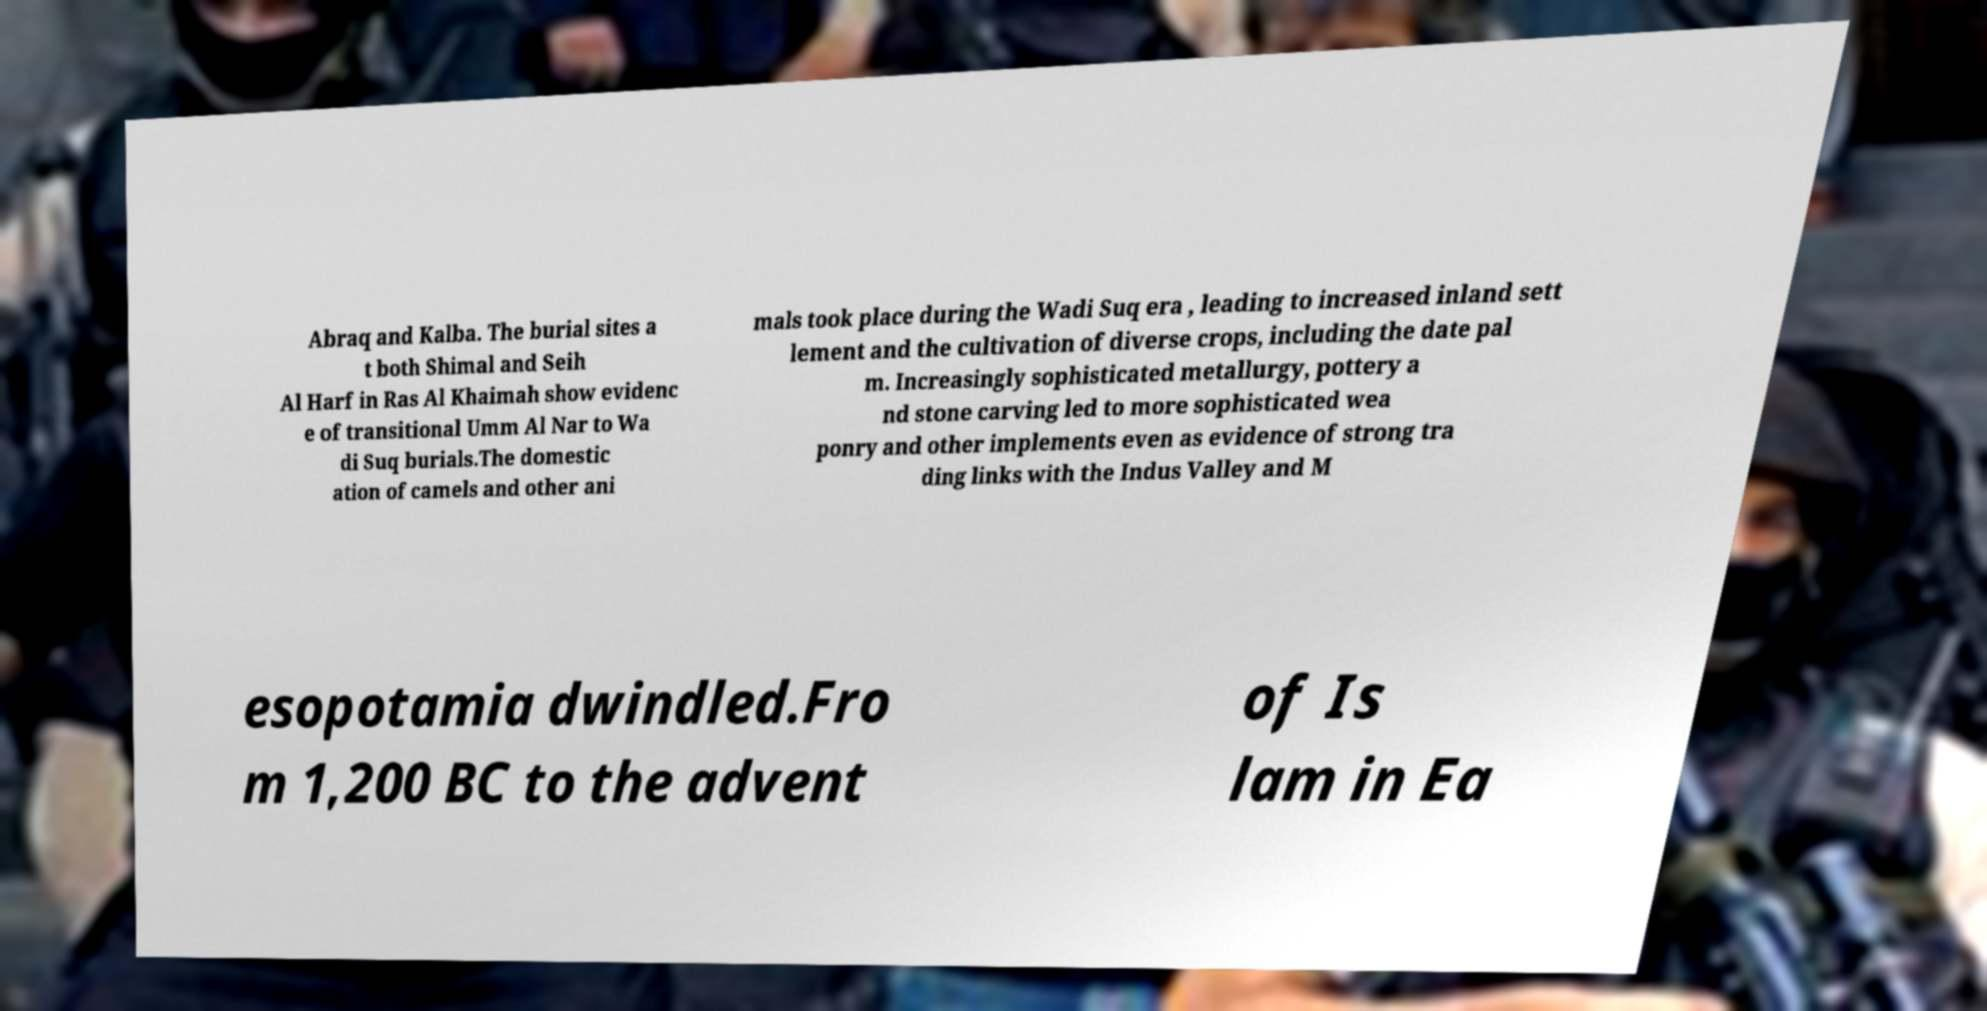Please read and relay the text visible in this image. What does it say? Abraq and Kalba. The burial sites a t both Shimal and Seih Al Harf in Ras Al Khaimah show evidenc e of transitional Umm Al Nar to Wa di Suq burials.The domestic ation of camels and other ani mals took place during the Wadi Suq era , leading to increased inland sett lement and the cultivation of diverse crops, including the date pal m. Increasingly sophisticated metallurgy, pottery a nd stone carving led to more sophisticated wea ponry and other implements even as evidence of strong tra ding links with the Indus Valley and M esopotamia dwindled.Fro m 1,200 BC to the advent of Is lam in Ea 